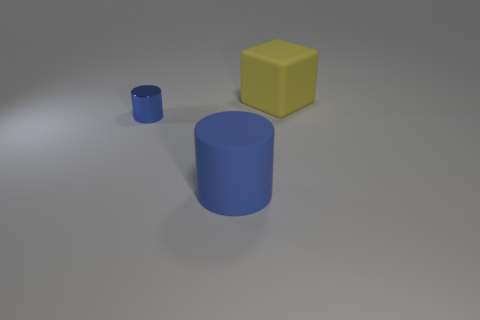Add 1 big blue cubes. How many objects exist? 4 Subtract all cubes. How many objects are left? 2 Add 2 yellow matte things. How many yellow matte things exist? 3 Subtract 0 purple cylinders. How many objects are left? 3 Subtract all large matte cylinders. Subtract all large yellow rubber things. How many objects are left? 1 Add 1 blue rubber cylinders. How many blue rubber cylinders are left? 2 